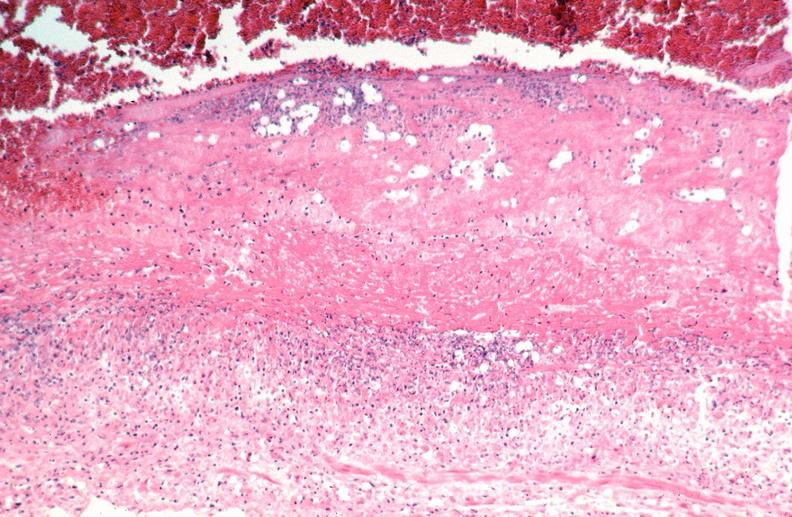does this image show vasculitis, polyarteritis nodosa?
Answer the question using a single word or phrase. Yes 